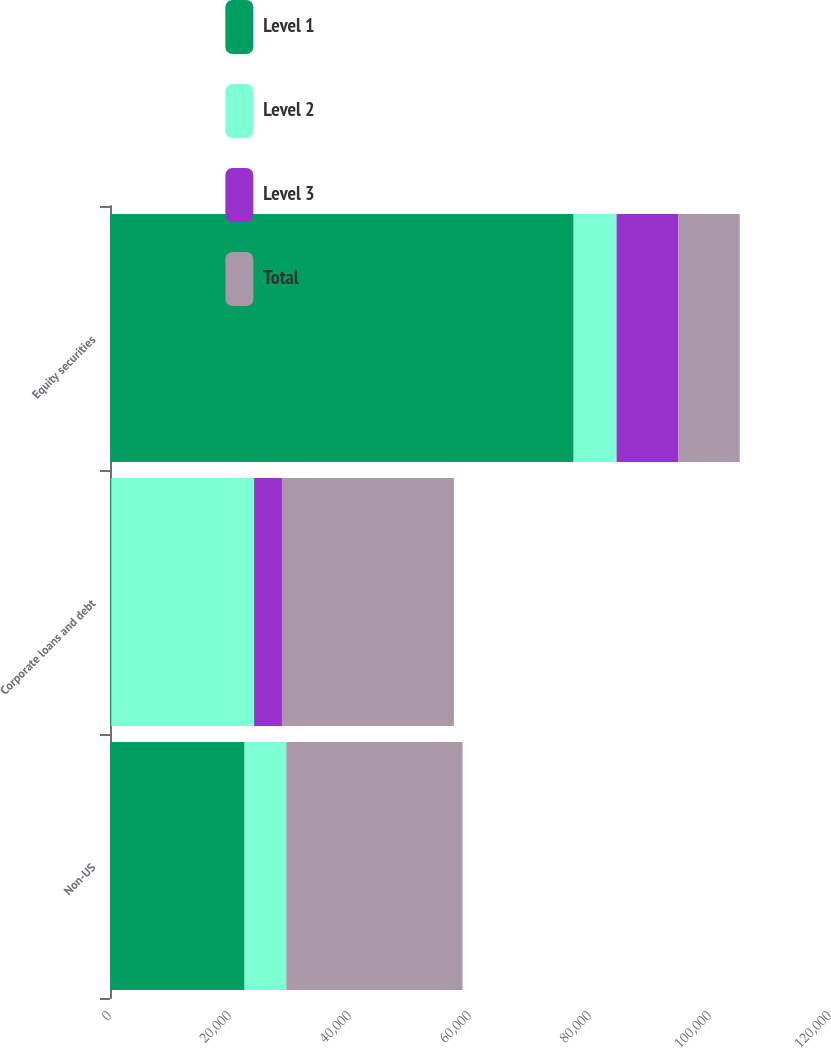Convert chart to OTSL. <chart><loc_0><loc_0><loc_500><loc_500><stacked_bar_chart><ecel><fcel>Non-US<fcel>Corporate loans and debt<fcel>Equity securities<nl><fcel>Level 1<fcel>22433<fcel>215<fcel>77276<nl><fcel>Level 2<fcel>6933<fcel>23804<fcel>7153<nl><fcel>Level 3<fcel>15<fcel>4640<fcel>10263<nl><fcel>Total<fcel>29381<fcel>28659<fcel>10263<nl></chart> 